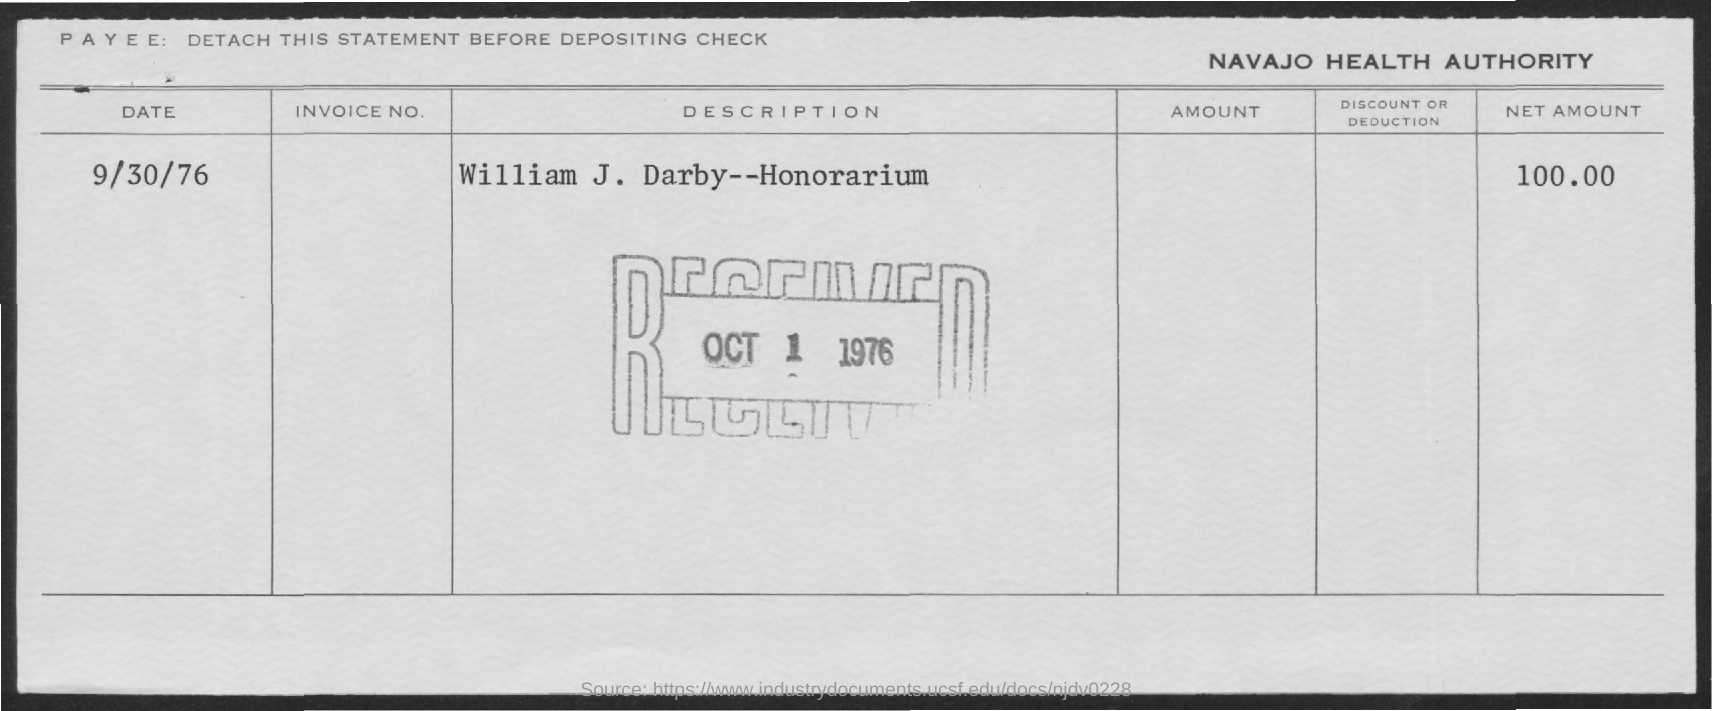What is the net amount of honorarium?
Provide a succinct answer. $ 100.00. What is the date of honorarium?
Give a very brief answer. 9/30/76. To whom is this honorarium to?
Ensure brevity in your answer.  William J. Darby. On what date is the honorarium received?
Give a very brief answer. OCT 1 1976. 